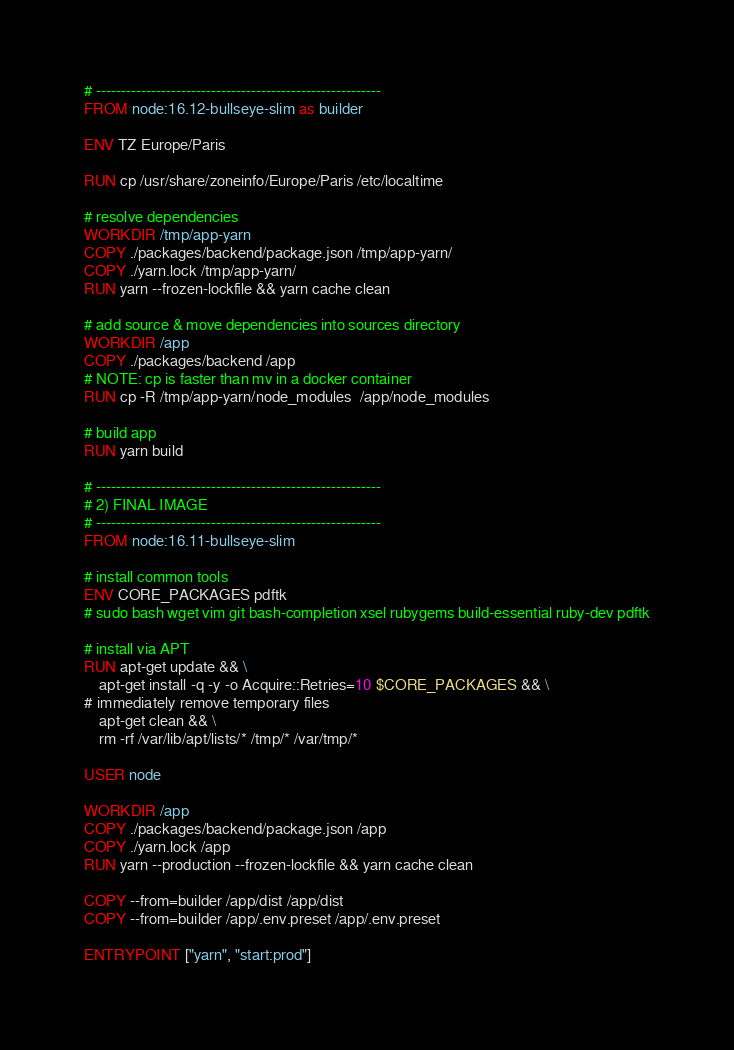<code> <loc_0><loc_0><loc_500><loc_500><_Dockerfile_># ---------------------------------------------------------
FROM node:16.12-bullseye-slim as builder

ENV TZ Europe/Paris

RUN cp /usr/share/zoneinfo/Europe/Paris /etc/localtime

# resolve dependencies
WORKDIR /tmp/app-yarn
COPY ./packages/backend/package.json /tmp/app-yarn/
COPY ./yarn.lock /tmp/app-yarn/
RUN yarn --frozen-lockfile && yarn cache clean

# add source & move dependencies into sources directory
WORKDIR /app
COPY ./packages/backend /app
# NOTE: cp is faster than mv in a docker container
RUN cp -R /tmp/app-yarn/node_modules  /app/node_modules 

# build app
RUN yarn build

# ---------------------------------------------------------
# 2) FINAL IMAGE
# ---------------------------------------------------------
FROM node:16.11-bullseye-slim

# install common tools
ENV CORE_PACKAGES pdftk
# sudo bash wget vim git bash-completion xsel rubygems build-essential ruby-dev pdftk

# install via APT
RUN apt-get update && \
    apt-get install -q -y -o Acquire::Retries=10 $CORE_PACKAGES && \
# immediately remove temporary files
    apt-get clean && \
    rm -rf /var/lib/apt/lists/* /tmp/* /var/tmp/*

USER node

WORKDIR /app
COPY ./packages/backend/package.json /app
COPY ./yarn.lock /app
RUN yarn --production --frozen-lockfile && yarn cache clean

COPY --from=builder /app/dist /app/dist
COPY --from=builder /app/.env.preset /app/.env.preset

ENTRYPOINT ["yarn", "start:prod"]
</code> 